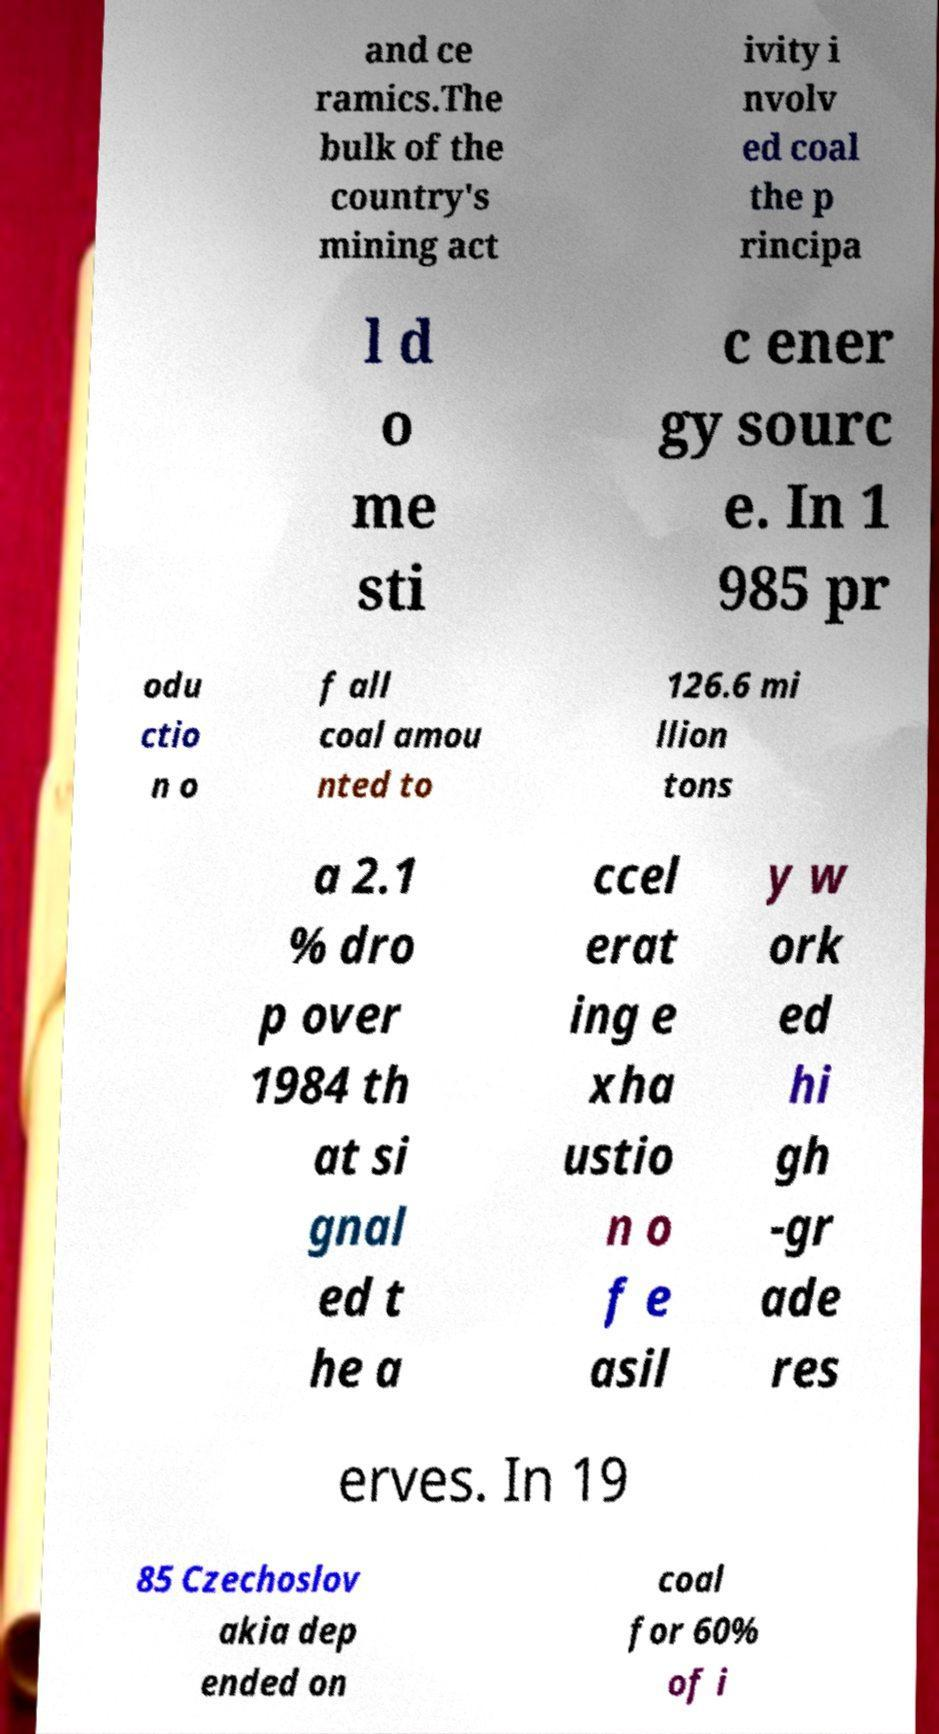Can you read and provide the text displayed in the image?This photo seems to have some interesting text. Can you extract and type it out for me? and ce ramics.The bulk of the country's mining act ivity i nvolv ed coal the p rincipa l d o me sti c ener gy sourc e. In 1 985 pr odu ctio n o f all coal amou nted to 126.6 mi llion tons a 2.1 % dro p over 1984 th at si gnal ed t he a ccel erat ing e xha ustio n o f e asil y w ork ed hi gh -gr ade res erves. In 19 85 Czechoslov akia dep ended on coal for 60% of i 